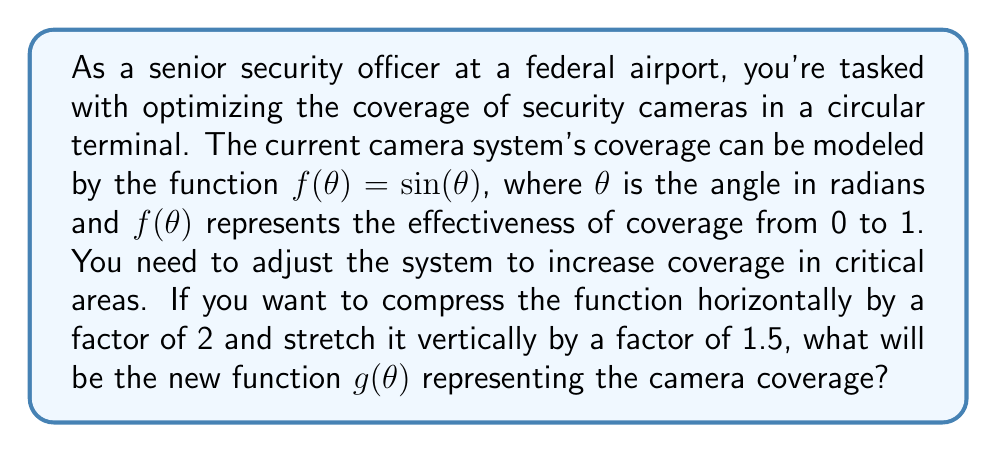Solve this math problem. To solve this problem, we need to apply transformations to the original function $f(\theta) = \sin(\theta)$. Let's break it down step-by-step:

1) First, let's consider the horizontal compression by a factor of 2. When we compress a function horizontally by a factor of $k$, we replace $\theta$ with $k\theta$ in the function. In this case, $k = 2$, so we get:

   $\sin(2\theta)$

2) Next, we need to apply the vertical stretch by a factor of 1.5. When we stretch a function vertically by a factor of $a$, we multiply the entire function by $a$. Here, $a = 1.5$, so we get:

   $1.5\sin(2\theta)$

3) Therefore, the new function $g(\theta)$ that represents the adjusted camera coverage is:

   $g(\theta) = 1.5\sin(2\theta)$

This new function will have peaks that are 1.5 times higher than the original function (representing increased effectiveness in those areas) and will complete two full cycles in the same angle range where the original function completed one cycle (representing more rapid changes in coverage as you move around the terminal).
Answer: $g(\theta) = 1.5\sin(2\theta)$ 